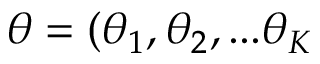Convert formula to latex. <formula><loc_0><loc_0><loc_500><loc_500>\theta = ( \theta _ { 1 } , \theta _ { 2 } , \dots \theta _ { K }</formula> 